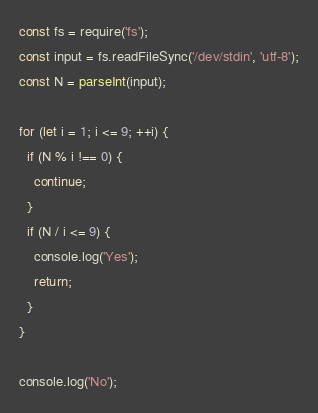<code> <loc_0><loc_0><loc_500><loc_500><_TypeScript_>const fs = require('fs');
const input = fs.readFileSync('/dev/stdin', 'utf-8');
const N = parseInt(input);

for (let i = 1; i <= 9; ++i) {
  if (N % i !== 0) {
    continue;
  }
  if (N / i <= 9) {
    console.log('Yes');
    return;
  }
}
    
console.log('No');</code> 